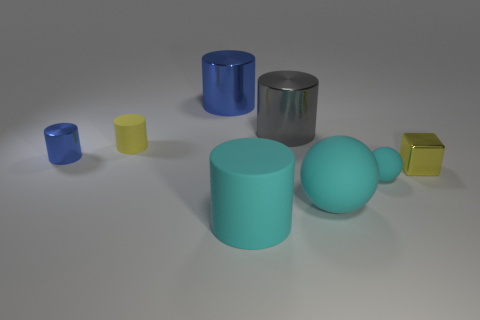Subtract all small blue shiny cylinders. How many cylinders are left? 4 Subtract all cylinders. How many objects are left? 3 Subtract 3 cylinders. How many cylinders are left? 2 Add 6 large gray things. How many large gray things exist? 7 Add 2 tiny cyan things. How many objects exist? 10 Subtract all cyan cylinders. How many cylinders are left? 4 Subtract 0 green blocks. How many objects are left? 8 Subtract all green cylinders. Subtract all brown balls. How many cylinders are left? 5 Subtract all red balls. How many brown cylinders are left? 0 Subtract all small yellow matte cylinders. Subtract all blue metal things. How many objects are left? 5 